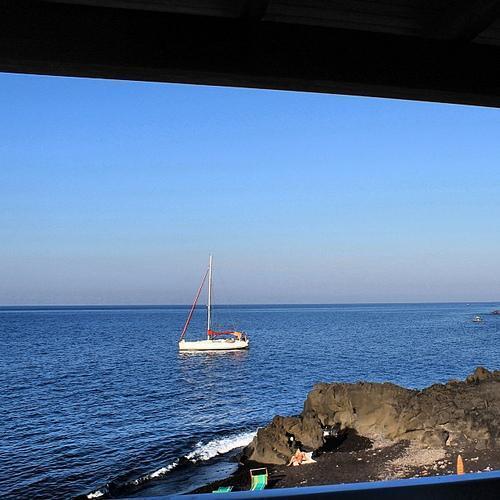How many boats are shown?
Give a very brief answer. 1. 